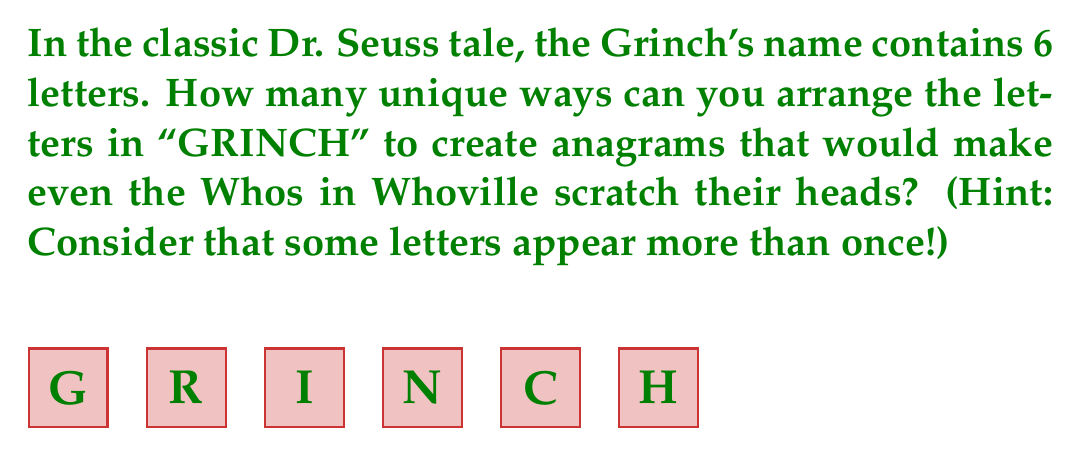Give your solution to this math problem. Let's approach this step-by-step:

1) First, we need to identify the number of each letter in "GRINCH":
   G: 1, R: 1, I: 1, N: 1, C: 1, H: 1

2) If all letters were different, we would have 6! arrangements. However, we need to account for repeated letters.

3) In this case, there are no repeated letters, so we don't need to divide by any factorial.

4) Therefore, the number of unique arrangements is simply:

   $$6! = 6 \times 5 \times 4 \times 3 \times 2 \times 1 = 720$$

5) This means there are 720 different ways to arrange the letters in "GRINCH".

Fun fact for Grinch fans: This is the same as the number of seconds in 12 minutes, which is about how long it takes the Grinch's heart to grow three sizes in the 1966 TV special!
Answer: $720$ 